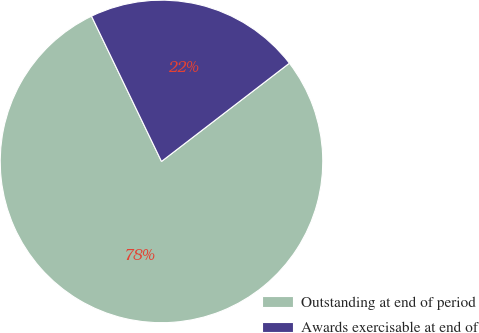<chart> <loc_0><loc_0><loc_500><loc_500><pie_chart><fcel>Outstanding at end of period<fcel>Awards exercisable at end of<nl><fcel>78.28%<fcel>21.72%<nl></chart> 